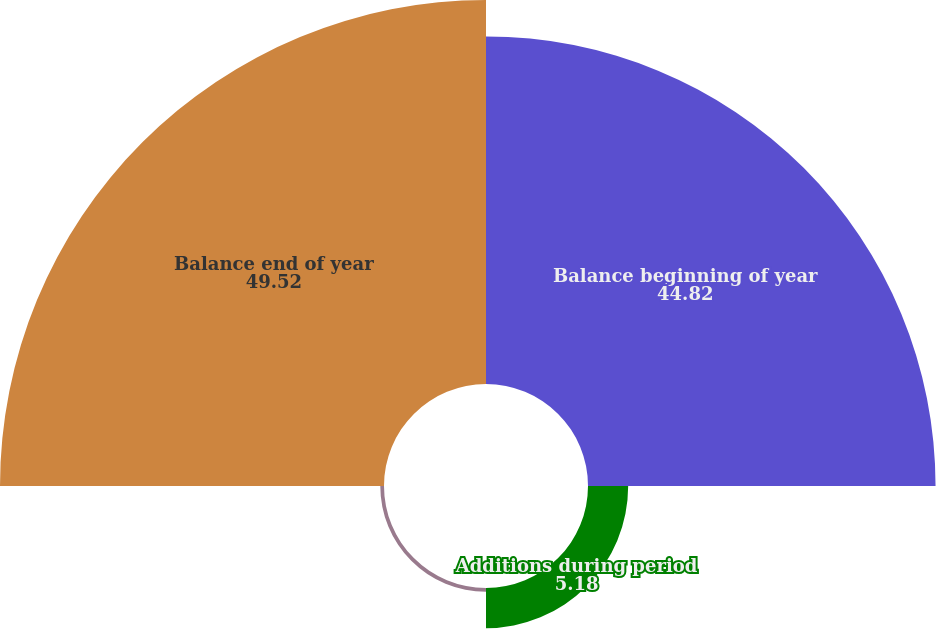<chart> <loc_0><loc_0><loc_500><loc_500><pie_chart><fcel>Balance beginning of year<fcel>Additions during period<fcel>Deductions during period<fcel>Balance end of year<nl><fcel>44.82%<fcel>5.18%<fcel>0.48%<fcel>49.52%<nl></chart> 